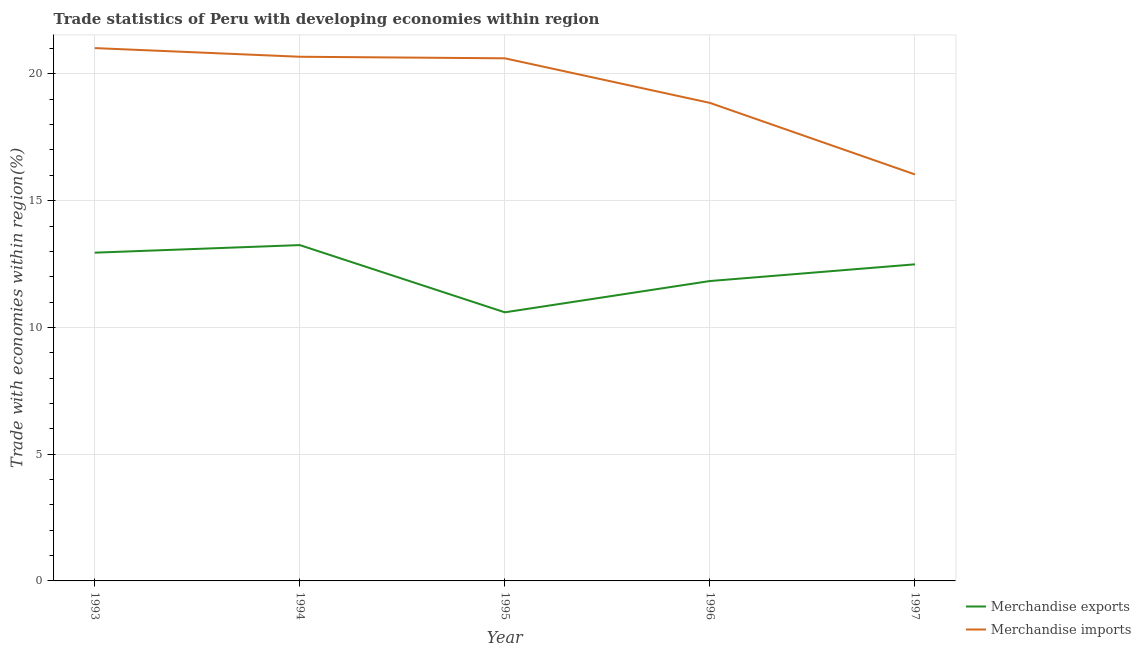What is the merchandise imports in 1997?
Provide a short and direct response. 16.04. Across all years, what is the maximum merchandise exports?
Make the answer very short. 13.25. Across all years, what is the minimum merchandise imports?
Provide a succinct answer. 16.04. In which year was the merchandise exports minimum?
Ensure brevity in your answer.  1995. What is the total merchandise imports in the graph?
Give a very brief answer. 97.21. What is the difference between the merchandise exports in 1994 and that in 1995?
Ensure brevity in your answer.  2.65. What is the difference between the merchandise exports in 1993 and the merchandise imports in 1997?
Your response must be concise. -3.09. What is the average merchandise imports per year?
Give a very brief answer. 19.44. In the year 1997, what is the difference between the merchandise imports and merchandise exports?
Your answer should be compact. 3.55. In how many years, is the merchandise imports greater than 20 %?
Your answer should be compact. 3. What is the ratio of the merchandise imports in 1993 to that in 1996?
Keep it short and to the point. 1.11. Is the merchandise exports in 1993 less than that in 1995?
Your response must be concise. No. Is the difference between the merchandise exports in 1993 and 1994 greater than the difference between the merchandise imports in 1993 and 1994?
Make the answer very short. No. What is the difference between the highest and the second highest merchandise imports?
Offer a very short reply. 0.34. What is the difference between the highest and the lowest merchandise imports?
Your answer should be compact. 4.98. In how many years, is the merchandise exports greater than the average merchandise exports taken over all years?
Offer a very short reply. 3. Does the merchandise exports monotonically increase over the years?
Your answer should be very brief. No. Is the merchandise imports strictly greater than the merchandise exports over the years?
Your answer should be very brief. Yes. Is the merchandise exports strictly less than the merchandise imports over the years?
Ensure brevity in your answer.  Yes. What is the difference between two consecutive major ticks on the Y-axis?
Ensure brevity in your answer.  5. Are the values on the major ticks of Y-axis written in scientific E-notation?
Provide a short and direct response. No. Does the graph contain any zero values?
Provide a short and direct response. No. Where does the legend appear in the graph?
Give a very brief answer. Bottom right. How many legend labels are there?
Make the answer very short. 2. How are the legend labels stacked?
Ensure brevity in your answer.  Vertical. What is the title of the graph?
Your answer should be very brief. Trade statistics of Peru with developing economies within region. Does "Female labourers" appear as one of the legend labels in the graph?
Your response must be concise. No. What is the label or title of the Y-axis?
Provide a succinct answer. Trade with economies within region(%). What is the Trade with economies within region(%) of Merchandise exports in 1993?
Keep it short and to the point. 12.95. What is the Trade with economies within region(%) of Merchandise imports in 1993?
Make the answer very short. 21.02. What is the Trade with economies within region(%) of Merchandise exports in 1994?
Ensure brevity in your answer.  13.25. What is the Trade with economies within region(%) of Merchandise imports in 1994?
Provide a succinct answer. 20.68. What is the Trade with economies within region(%) in Merchandise exports in 1995?
Provide a short and direct response. 10.6. What is the Trade with economies within region(%) in Merchandise imports in 1995?
Your response must be concise. 20.62. What is the Trade with economies within region(%) of Merchandise exports in 1996?
Keep it short and to the point. 11.83. What is the Trade with economies within region(%) of Merchandise imports in 1996?
Make the answer very short. 18.86. What is the Trade with economies within region(%) in Merchandise exports in 1997?
Offer a terse response. 12.49. What is the Trade with economies within region(%) in Merchandise imports in 1997?
Your answer should be compact. 16.04. Across all years, what is the maximum Trade with economies within region(%) of Merchandise exports?
Provide a succinct answer. 13.25. Across all years, what is the maximum Trade with economies within region(%) in Merchandise imports?
Make the answer very short. 21.02. Across all years, what is the minimum Trade with economies within region(%) in Merchandise exports?
Offer a terse response. 10.6. Across all years, what is the minimum Trade with economies within region(%) of Merchandise imports?
Offer a terse response. 16.04. What is the total Trade with economies within region(%) in Merchandise exports in the graph?
Make the answer very short. 61.11. What is the total Trade with economies within region(%) of Merchandise imports in the graph?
Give a very brief answer. 97.21. What is the difference between the Trade with economies within region(%) in Merchandise exports in 1993 and that in 1994?
Provide a succinct answer. -0.3. What is the difference between the Trade with economies within region(%) in Merchandise imports in 1993 and that in 1994?
Offer a terse response. 0.34. What is the difference between the Trade with economies within region(%) of Merchandise exports in 1993 and that in 1995?
Your response must be concise. 2.35. What is the difference between the Trade with economies within region(%) in Merchandise imports in 1993 and that in 1995?
Provide a short and direct response. 0.4. What is the difference between the Trade with economies within region(%) of Merchandise exports in 1993 and that in 1996?
Provide a succinct answer. 1.12. What is the difference between the Trade with economies within region(%) of Merchandise imports in 1993 and that in 1996?
Provide a succinct answer. 2.16. What is the difference between the Trade with economies within region(%) in Merchandise exports in 1993 and that in 1997?
Offer a terse response. 0.46. What is the difference between the Trade with economies within region(%) in Merchandise imports in 1993 and that in 1997?
Make the answer very short. 4.98. What is the difference between the Trade with economies within region(%) in Merchandise exports in 1994 and that in 1995?
Your response must be concise. 2.65. What is the difference between the Trade with economies within region(%) of Merchandise imports in 1994 and that in 1995?
Provide a short and direct response. 0.06. What is the difference between the Trade with economies within region(%) in Merchandise exports in 1994 and that in 1996?
Keep it short and to the point. 1.42. What is the difference between the Trade with economies within region(%) of Merchandise imports in 1994 and that in 1996?
Offer a terse response. 1.82. What is the difference between the Trade with economies within region(%) in Merchandise exports in 1994 and that in 1997?
Offer a terse response. 0.76. What is the difference between the Trade with economies within region(%) in Merchandise imports in 1994 and that in 1997?
Offer a very short reply. 4.64. What is the difference between the Trade with economies within region(%) of Merchandise exports in 1995 and that in 1996?
Make the answer very short. -1.23. What is the difference between the Trade with economies within region(%) in Merchandise imports in 1995 and that in 1996?
Your answer should be compact. 1.76. What is the difference between the Trade with economies within region(%) of Merchandise exports in 1995 and that in 1997?
Your response must be concise. -1.89. What is the difference between the Trade with economies within region(%) in Merchandise imports in 1995 and that in 1997?
Ensure brevity in your answer.  4.58. What is the difference between the Trade with economies within region(%) of Merchandise exports in 1996 and that in 1997?
Provide a short and direct response. -0.66. What is the difference between the Trade with economies within region(%) in Merchandise imports in 1996 and that in 1997?
Your answer should be compact. 2.82. What is the difference between the Trade with economies within region(%) in Merchandise exports in 1993 and the Trade with economies within region(%) in Merchandise imports in 1994?
Make the answer very short. -7.73. What is the difference between the Trade with economies within region(%) in Merchandise exports in 1993 and the Trade with economies within region(%) in Merchandise imports in 1995?
Provide a succinct answer. -7.67. What is the difference between the Trade with economies within region(%) of Merchandise exports in 1993 and the Trade with economies within region(%) of Merchandise imports in 1996?
Offer a very short reply. -5.91. What is the difference between the Trade with economies within region(%) in Merchandise exports in 1993 and the Trade with economies within region(%) in Merchandise imports in 1997?
Offer a very short reply. -3.09. What is the difference between the Trade with economies within region(%) of Merchandise exports in 1994 and the Trade with economies within region(%) of Merchandise imports in 1995?
Your answer should be compact. -7.37. What is the difference between the Trade with economies within region(%) in Merchandise exports in 1994 and the Trade with economies within region(%) in Merchandise imports in 1996?
Provide a short and direct response. -5.61. What is the difference between the Trade with economies within region(%) in Merchandise exports in 1994 and the Trade with economies within region(%) in Merchandise imports in 1997?
Ensure brevity in your answer.  -2.79. What is the difference between the Trade with economies within region(%) of Merchandise exports in 1995 and the Trade with economies within region(%) of Merchandise imports in 1996?
Your response must be concise. -8.26. What is the difference between the Trade with economies within region(%) of Merchandise exports in 1995 and the Trade with economies within region(%) of Merchandise imports in 1997?
Provide a succinct answer. -5.44. What is the difference between the Trade with economies within region(%) in Merchandise exports in 1996 and the Trade with economies within region(%) in Merchandise imports in 1997?
Your answer should be very brief. -4.21. What is the average Trade with economies within region(%) of Merchandise exports per year?
Offer a terse response. 12.22. What is the average Trade with economies within region(%) in Merchandise imports per year?
Offer a terse response. 19.44. In the year 1993, what is the difference between the Trade with economies within region(%) in Merchandise exports and Trade with economies within region(%) in Merchandise imports?
Make the answer very short. -8.07. In the year 1994, what is the difference between the Trade with economies within region(%) in Merchandise exports and Trade with economies within region(%) in Merchandise imports?
Give a very brief answer. -7.43. In the year 1995, what is the difference between the Trade with economies within region(%) of Merchandise exports and Trade with economies within region(%) of Merchandise imports?
Keep it short and to the point. -10.02. In the year 1996, what is the difference between the Trade with economies within region(%) in Merchandise exports and Trade with economies within region(%) in Merchandise imports?
Your answer should be very brief. -7.03. In the year 1997, what is the difference between the Trade with economies within region(%) of Merchandise exports and Trade with economies within region(%) of Merchandise imports?
Your answer should be very brief. -3.55. What is the ratio of the Trade with economies within region(%) of Merchandise exports in 1993 to that in 1994?
Give a very brief answer. 0.98. What is the ratio of the Trade with economies within region(%) of Merchandise imports in 1993 to that in 1994?
Make the answer very short. 1.02. What is the ratio of the Trade with economies within region(%) in Merchandise exports in 1993 to that in 1995?
Give a very brief answer. 1.22. What is the ratio of the Trade with economies within region(%) of Merchandise imports in 1993 to that in 1995?
Offer a terse response. 1.02. What is the ratio of the Trade with economies within region(%) of Merchandise exports in 1993 to that in 1996?
Offer a terse response. 1.09. What is the ratio of the Trade with economies within region(%) in Merchandise imports in 1993 to that in 1996?
Your answer should be compact. 1.11. What is the ratio of the Trade with economies within region(%) of Merchandise exports in 1993 to that in 1997?
Ensure brevity in your answer.  1.04. What is the ratio of the Trade with economies within region(%) in Merchandise imports in 1993 to that in 1997?
Ensure brevity in your answer.  1.31. What is the ratio of the Trade with economies within region(%) in Merchandise exports in 1994 to that in 1995?
Provide a succinct answer. 1.25. What is the ratio of the Trade with economies within region(%) of Merchandise exports in 1994 to that in 1996?
Provide a short and direct response. 1.12. What is the ratio of the Trade with economies within region(%) in Merchandise imports in 1994 to that in 1996?
Offer a very short reply. 1.1. What is the ratio of the Trade with economies within region(%) of Merchandise exports in 1994 to that in 1997?
Keep it short and to the point. 1.06. What is the ratio of the Trade with economies within region(%) in Merchandise imports in 1994 to that in 1997?
Keep it short and to the point. 1.29. What is the ratio of the Trade with economies within region(%) of Merchandise exports in 1995 to that in 1996?
Ensure brevity in your answer.  0.9. What is the ratio of the Trade with economies within region(%) in Merchandise imports in 1995 to that in 1996?
Make the answer very short. 1.09. What is the ratio of the Trade with economies within region(%) in Merchandise exports in 1995 to that in 1997?
Your answer should be compact. 0.85. What is the ratio of the Trade with economies within region(%) in Merchandise imports in 1995 to that in 1997?
Provide a short and direct response. 1.29. What is the ratio of the Trade with economies within region(%) in Merchandise exports in 1996 to that in 1997?
Provide a succinct answer. 0.95. What is the ratio of the Trade with economies within region(%) in Merchandise imports in 1996 to that in 1997?
Your response must be concise. 1.18. What is the difference between the highest and the second highest Trade with economies within region(%) in Merchandise exports?
Provide a short and direct response. 0.3. What is the difference between the highest and the second highest Trade with economies within region(%) in Merchandise imports?
Your answer should be very brief. 0.34. What is the difference between the highest and the lowest Trade with economies within region(%) in Merchandise exports?
Make the answer very short. 2.65. What is the difference between the highest and the lowest Trade with economies within region(%) in Merchandise imports?
Give a very brief answer. 4.98. 